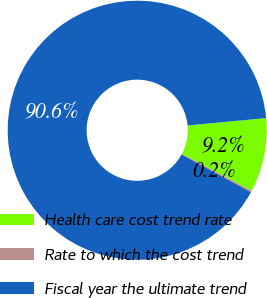<chart> <loc_0><loc_0><loc_500><loc_500><pie_chart><fcel>Health care cost trend rate<fcel>Rate to which the cost trend<fcel>Fiscal year the ultimate trend<nl><fcel>9.24%<fcel>0.2%<fcel>90.56%<nl></chart> 